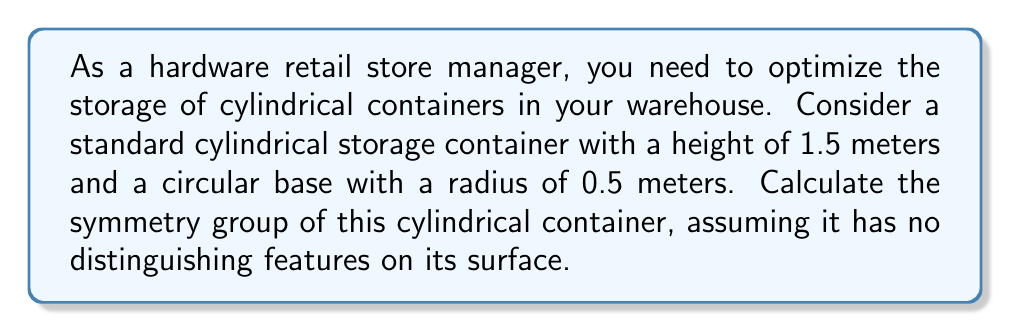Solve this math problem. To calculate the symmetry group of the cylindrical storage container, we need to consider all the transformations that leave the cylinder unchanged. Let's break this down step-by-step:

1. Rotational symmetry:
   The cylinder has continuous rotational symmetry around its central axis. This means we can rotate it by any angle $\theta$ around its axis, and it will look the same. Mathematically, this is represented by the group $SO(2)$.

2. Reflection symmetry:
   The cylinder has an infinite number of reflection planes that contain the central axis. Any plane that cuts the cylinder in half vertically is a plane of symmetry.

3. Up-down reflection:
   There is also a reflection symmetry across the horizontal plane that bisects the cylinder at half its height.

4. Translational symmetry:
   Since the cylinder is finite in height, it does not have translational symmetry along its axis.

The symmetry group of the cylinder is a combination of these symmetries. In Lie group notation, this can be expressed as:

$$ G = O(2) \times \mathbb{Z}_2 $$

Where:
- $O(2)$ represents the 2-dimensional orthogonal group, which includes both rotations ($SO(2)$) and reflections in the plane.
- $\mathbb{Z}_2$ represents the up-down reflection symmetry.

In more detail:
- $O(2)$ captures the rotational symmetry around the axis and the reflections across vertical planes.
- $\mathbb{Z}_2$ captures the reflection across the horizontal bisecting plane.

This group is sometimes referred to as $D_{\infty h}$ in molecular symmetry notation, where:
- $D$ stands for dihedral (rotations and reflections in the plane)
- $\infty$ indicates continuous rotational symmetry
- $h$ denotes the horizontal reflection plane

The dimension of this symmetry group is 1 (from the 1-dimensional rotations) + 0 (from the discrete reflections) = 1.
Answer: The symmetry group of the cylindrical storage container is $O(2) \times \mathbb{Z}_2$, also known as $D_{\infty h}$ in molecular symmetry notation. It has a dimension of 1. 